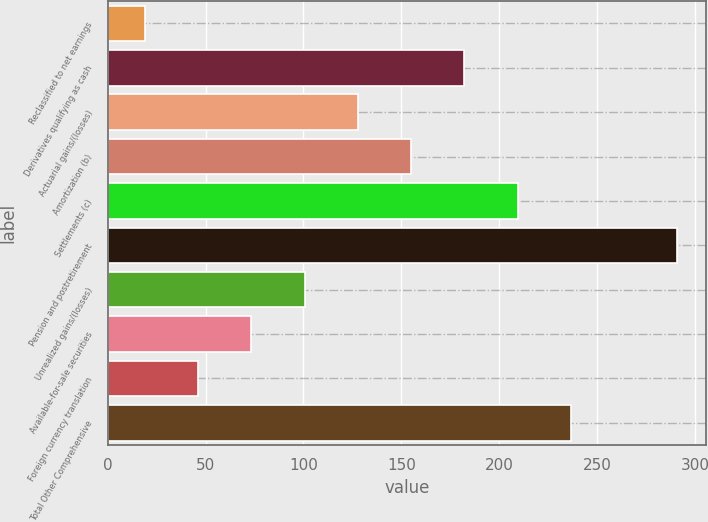<chart> <loc_0><loc_0><loc_500><loc_500><bar_chart><fcel>Reclassified to net earnings<fcel>Derivatives qualifying as cash<fcel>Actuarial gains/(losses)<fcel>Amortization (b)<fcel>Settlements (c)<fcel>Pension and postretirement<fcel>Unrealized gains/(losses)<fcel>Available-for-sale securities<fcel>Foreign currency translation<fcel>Total Other Comprehensive<nl><fcel>19<fcel>182.2<fcel>127.8<fcel>155<fcel>209.4<fcel>291<fcel>100.6<fcel>73.4<fcel>46.2<fcel>236.6<nl></chart> 